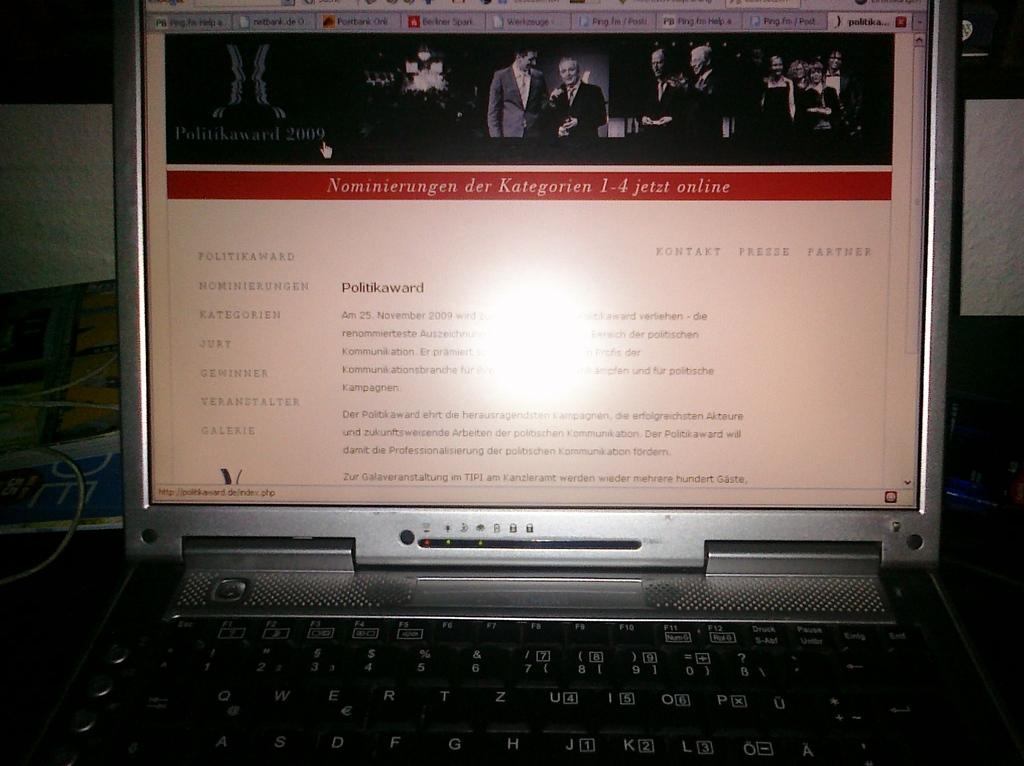What is the title of the article?
Give a very brief answer. Politikaward. 